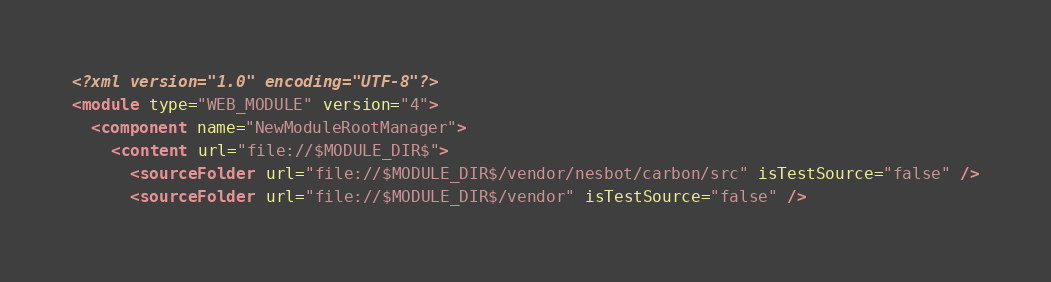Convert code to text. <code><loc_0><loc_0><loc_500><loc_500><_XML_><?xml version="1.0" encoding="UTF-8"?>
<module type="WEB_MODULE" version="4">
  <component name="NewModuleRootManager">
    <content url="file://$MODULE_DIR$">
      <sourceFolder url="file://$MODULE_DIR$/vendor/nesbot/carbon/src" isTestSource="false" />
      <sourceFolder url="file://$MODULE_DIR$/vendor" isTestSource="false" /></code> 